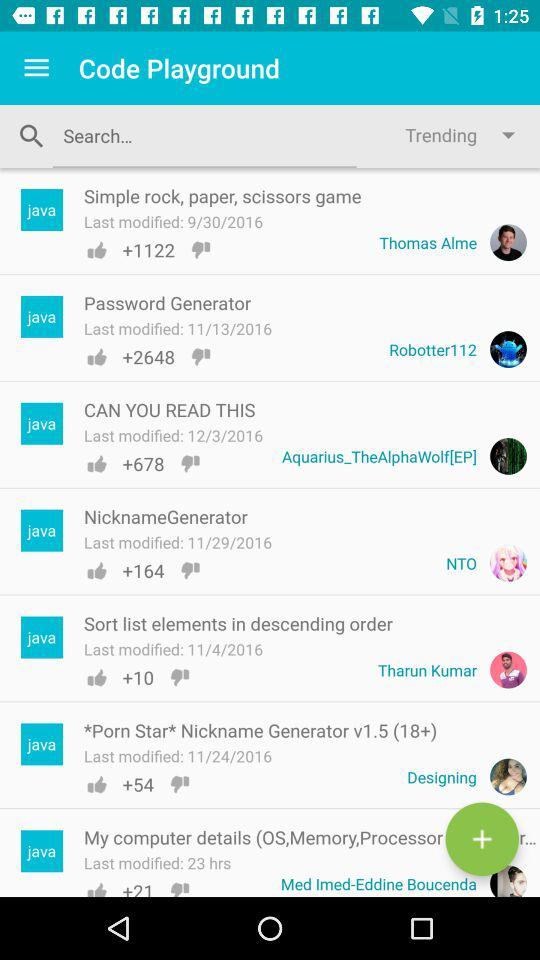How many thumbs up does the NicknameGenerator have?
Answer the question using a single word or phrase. 164 